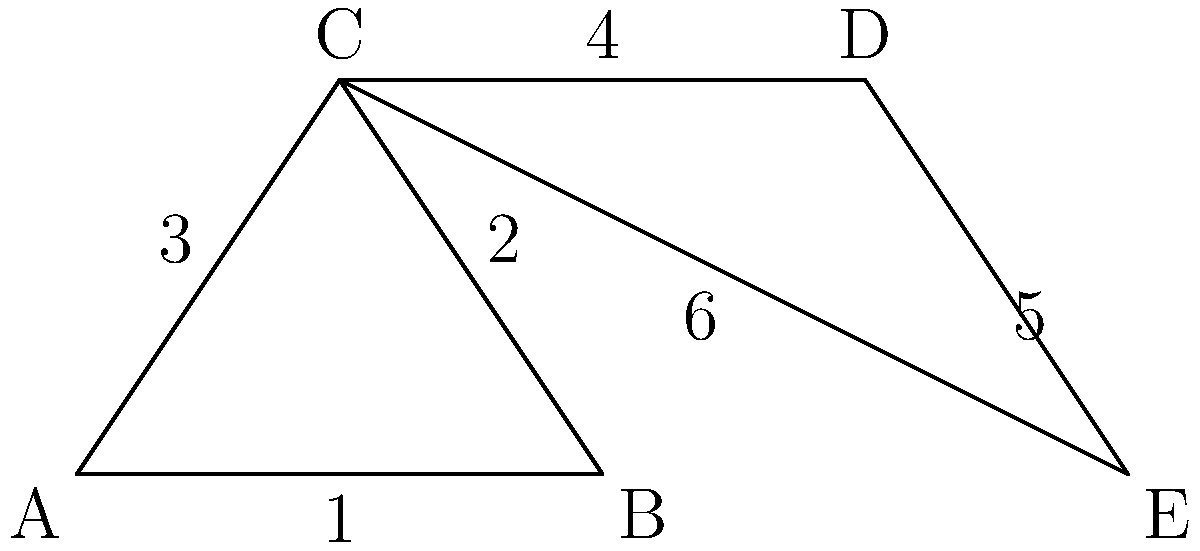In the product assembly diagram above, which two triangles are congruent? Identify them by their vertex labels. To determine if two triangles are congruent, we need to check if they satisfy one of the congruence criteria: SSS (Side-Side-Side), SAS (Side-Angle-Side), or ASA (Angle-Side-Angle).

Let's examine the triangles in the diagram:

1. Triangle ABC:
   - Side 1: AB
   - Side 2: BC
   - Side 3: AC

2. Triangle CDE:
   - Side 4: CD
   - Side 5: DE
   - Side 6: CE

We can see that:
- Side 4 (CD) is equal to Side 2 (BC) as they form a straight line
- Side 6 (CE) is equal to Side 3 (AC) as they are opposite sides of a parallelogram
- The angle at vertex C is common to both triangles

This satisfies the SAS (Side-Angle-Side) congruence criterion, which states that if two sides and the included angle of one triangle are equal to the corresponding parts of another triangle, the triangles are congruent.

Therefore, triangle ABC is congruent to triangle CDE.
Answer: ABC and CDE 